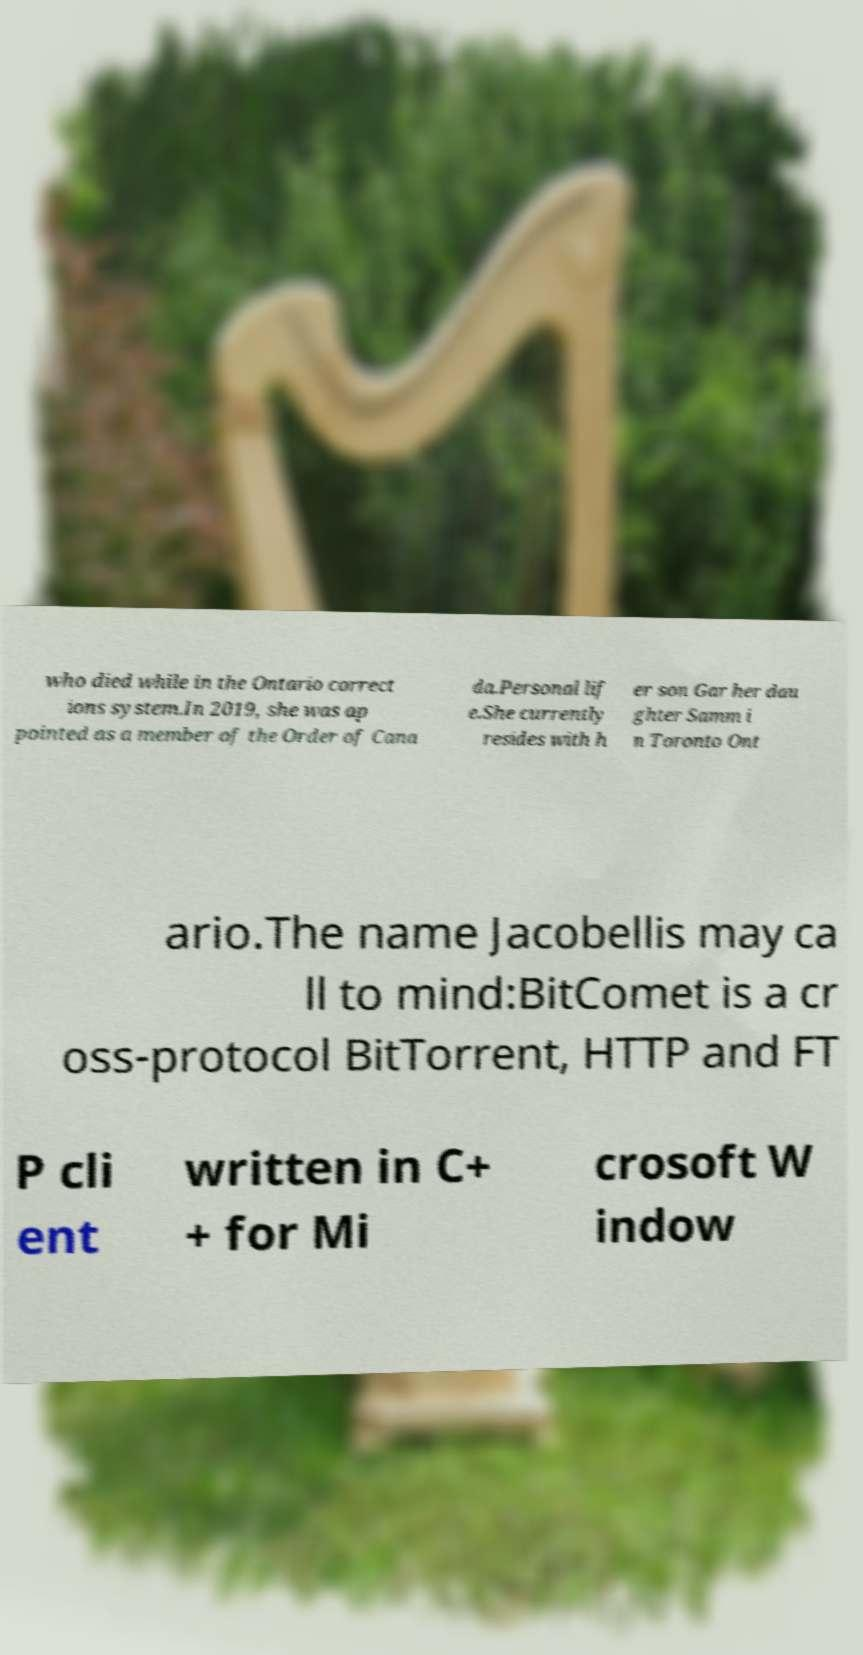Can you accurately transcribe the text from the provided image for me? who died while in the Ontario correct ions system.In 2019, she was ap pointed as a member of the Order of Cana da.Personal lif e.She currently resides with h er son Gar her dau ghter Samm i n Toronto Ont ario.The name Jacobellis may ca ll to mind:BitComet is a cr oss-protocol BitTorrent, HTTP and FT P cli ent written in C+ + for Mi crosoft W indow 